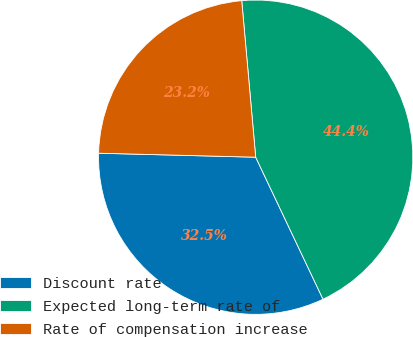Convert chart. <chart><loc_0><loc_0><loc_500><loc_500><pie_chart><fcel>Discount rate<fcel>Expected long-term rate of<fcel>Rate of compensation increase<nl><fcel>32.45%<fcel>44.37%<fcel>23.18%<nl></chart> 